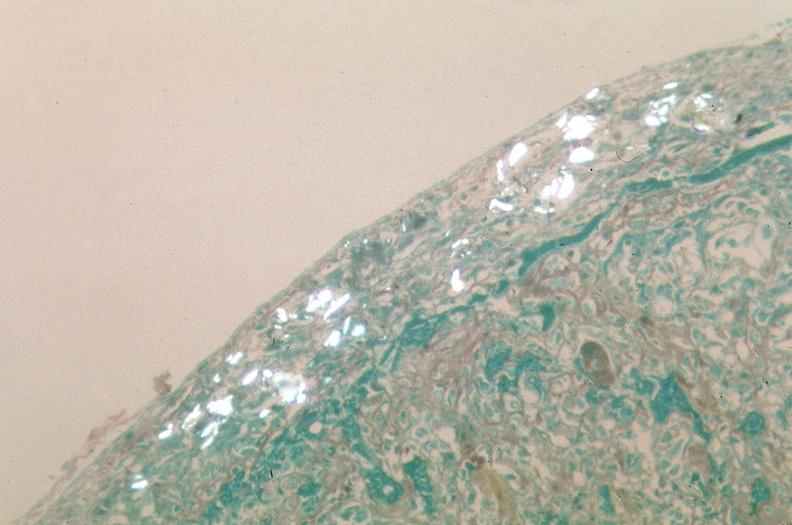does lesion cross stain?
Answer the question using a single word or phrase. No 